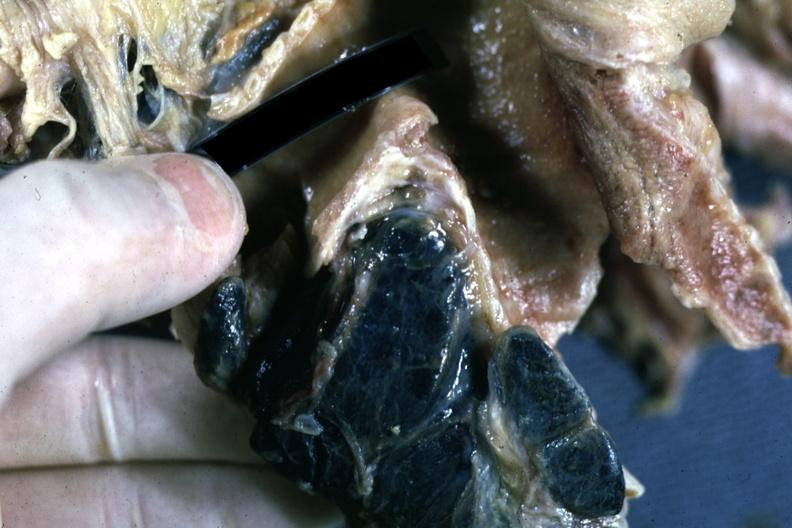how is fixed tissue sectioned nodes shown close-up nodes are filled with black pigment?
Answer the question using a single word or phrase. Carinal 